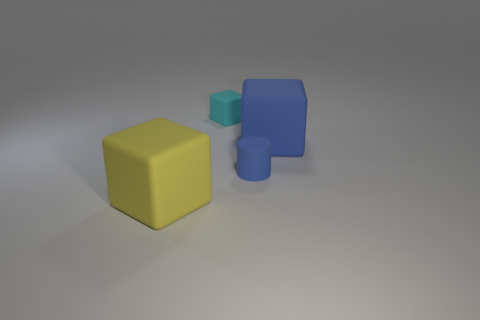How many big matte objects have the same color as the tiny rubber cylinder?
Offer a very short reply. 1. There is a tiny cube that is made of the same material as the tiny cylinder; what color is it?
Ensure brevity in your answer.  Cyan. The large matte block that is in front of the blue rubber object that is in front of the big matte cube that is behind the yellow matte object is what color?
Make the answer very short. Yellow. Do the cyan rubber thing and the yellow object that is to the left of the cyan matte object have the same size?
Provide a succinct answer. No. How many things are either big matte cubes that are right of the yellow matte cube or large rubber objects that are behind the small blue rubber thing?
Provide a short and direct response. 1. There is another rubber object that is the same size as the yellow object; what shape is it?
Ensure brevity in your answer.  Cube. What is the shape of the big thing that is behind the large cube that is left of the small matte object behind the blue rubber cylinder?
Provide a short and direct response. Cube. Are there the same number of yellow matte cubes behind the cyan block and brown rubber cylinders?
Your answer should be very brief. Yes. Is the size of the blue cylinder the same as the cyan object?
Provide a succinct answer. Yes. How many shiny things are either tiny yellow blocks or cylinders?
Keep it short and to the point. 0. 